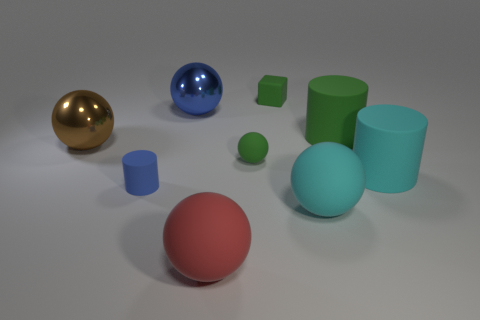Subtract all cyan balls. How many balls are left? 4 Subtract all green balls. How many balls are left? 4 Subtract 2 balls. How many balls are left? 3 Subtract all gray spheres. Subtract all blue blocks. How many spheres are left? 5 Subtract all blocks. How many objects are left? 8 Subtract all large red balls. Subtract all blue metal objects. How many objects are left? 7 Add 4 large cyan things. How many large cyan things are left? 6 Add 3 gray balls. How many gray balls exist? 3 Subtract 0 red cubes. How many objects are left? 9 